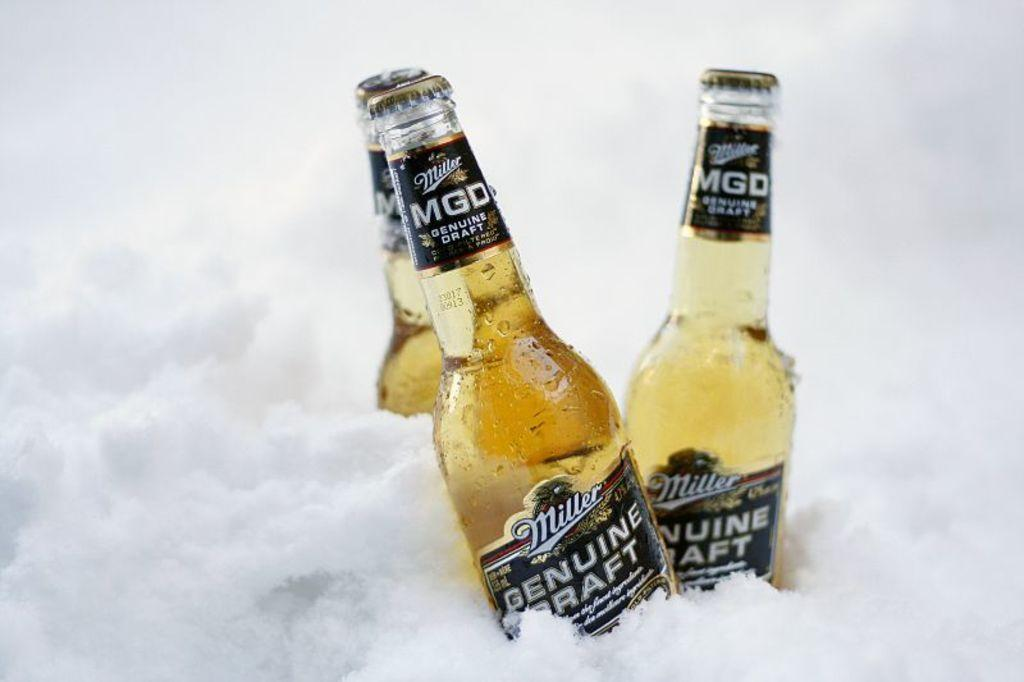<image>
Offer a succinct explanation of the picture presented. Three beer beer bottles from the brand "Millers". 